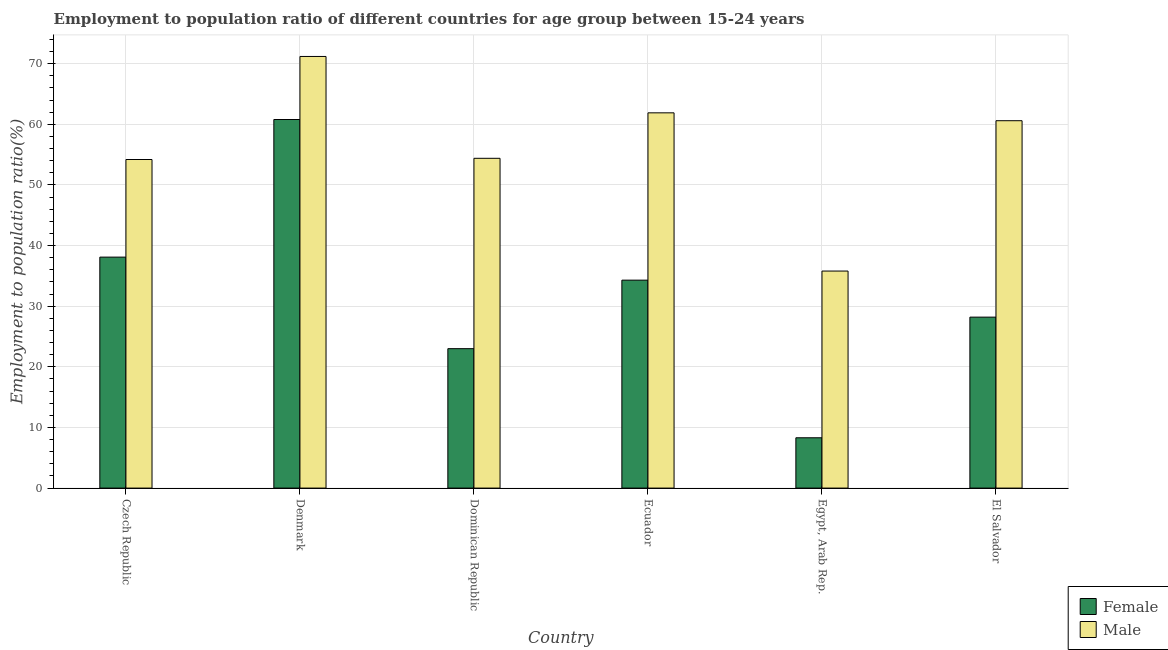Are the number of bars per tick equal to the number of legend labels?
Give a very brief answer. Yes. Are the number of bars on each tick of the X-axis equal?
Your answer should be very brief. Yes. How many bars are there on the 4th tick from the left?
Provide a succinct answer. 2. What is the label of the 6th group of bars from the left?
Keep it short and to the point. El Salvador. In how many cases, is the number of bars for a given country not equal to the number of legend labels?
Offer a terse response. 0. What is the employment to population ratio(female) in El Salvador?
Offer a very short reply. 28.2. Across all countries, what is the maximum employment to population ratio(male)?
Your answer should be very brief. 71.2. Across all countries, what is the minimum employment to population ratio(male)?
Your answer should be very brief. 35.8. In which country was the employment to population ratio(female) minimum?
Provide a short and direct response. Egypt, Arab Rep. What is the total employment to population ratio(male) in the graph?
Give a very brief answer. 338.1. What is the difference between the employment to population ratio(male) in Egypt, Arab Rep. and that in El Salvador?
Keep it short and to the point. -24.8. What is the difference between the employment to population ratio(female) in Egypt, Arab Rep. and the employment to population ratio(male) in Czech Republic?
Your response must be concise. -45.9. What is the average employment to population ratio(female) per country?
Give a very brief answer. 32.12. What is the difference between the employment to population ratio(male) and employment to population ratio(female) in Egypt, Arab Rep.?
Your answer should be compact. 27.5. In how many countries, is the employment to population ratio(male) greater than 46 %?
Your answer should be compact. 5. What is the ratio of the employment to population ratio(female) in Czech Republic to that in Egypt, Arab Rep.?
Keep it short and to the point. 4.59. Is the employment to population ratio(male) in Dominican Republic less than that in Egypt, Arab Rep.?
Offer a terse response. No. What is the difference between the highest and the second highest employment to population ratio(male)?
Offer a very short reply. 9.3. What is the difference between the highest and the lowest employment to population ratio(male)?
Ensure brevity in your answer.  35.4. In how many countries, is the employment to population ratio(female) greater than the average employment to population ratio(female) taken over all countries?
Your response must be concise. 3. Is the sum of the employment to population ratio(male) in Czech Republic and Denmark greater than the maximum employment to population ratio(female) across all countries?
Offer a terse response. Yes. What does the 2nd bar from the left in El Salvador represents?
Your answer should be compact. Male. What does the 1st bar from the right in Czech Republic represents?
Offer a terse response. Male. How many bars are there?
Give a very brief answer. 12. How many countries are there in the graph?
Ensure brevity in your answer.  6. Does the graph contain any zero values?
Give a very brief answer. No. Does the graph contain grids?
Keep it short and to the point. Yes. Where does the legend appear in the graph?
Your response must be concise. Bottom right. What is the title of the graph?
Keep it short and to the point. Employment to population ratio of different countries for age group between 15-24 years. Does "Registered firms" appear as one of the legend labels in the graph?
Keep it short and to the point. No. What is the label or title of the Y-axis?
Your answer should be very brief. Employment to population ratio(%). What is the Employment to population ratio(%) of Female in Czech Republic?
Your response must be concise. 38.1. What is the Employment to population ratio(%) of Male in Czech Republic?
Your response must be concise. 54.2. What is the Employment to population ratio(%) in Female in Denmark?
Make the answer very short. 60.8. What is the Employment to population ratio(%) in Male in Denmark?
Keep it short and to the point. 71.2. What is the Employment to population ratio(%) of Male in Dominican Republic?
Keep it short and to the point. 54.4. What is the Employment to population ratio(%) in Female in Ecuador?
Provide a short and direct response. 34.3. What is the Employment to population ratio(%) of Male in Ecuador?
Provide a short and direct response. 61.9. What is the Employment to population ratio(%) of Female in Egypt, Arab Rep.?
Your response must be concise. 8.3. What is the Employment to population ratio(%) in Male in Egypt, Arab Rep.?
Offer a very short reply. 35.8. What is the Employment to population ratio(%) in Female in El Salvador?
Ensure brevity in your answer.  28.2. What is the Employment to population ratio(%) of Male in El Salvador?
Offer a very short reply. 60.6. Across all countries, what is the maximum Employment to population ratio(%) in Female?
Ensure brevity in your answer.  60.8. Across all countries, what is the maximum Employment to population ratio(%) in Male?
Ensure brevity in your answer.  71.2. Across all countries, what is the minimum Employment to population ratio(%) of Female?
Make the answer very short. 8.3. Across all countries, what is the minimum Employment to population ratio(%) of Male?
Provide a succinct answer. 35.8. What is the total Employment to population ratio(%) in Female in the graph?
Give a very brief answer. 192.7. What is the total Employment to population ratio(%) in Male in the graph?
Offer a terse response. 338.1. What is the difference between the Employment to population ratio(%) of Female in Czech Republic and that in Denmark?
Give a very brief answer. -22.7. What is the difference between the Employment to population ratio(%) of Female in Czech Republic and that in Egypt, Arab Rep.?
Provide a short and direct response. 29.8. What is the difference between the Employment to population ratio(%) of Female in Denmark and that in Dominican Republic?
Your response must be concise. 37.8. What is the difference between the Employment to population ratio(%) in Male in Denmark and that in Dominican Republic?
Offer a terse response. 16.8. What is the difference between the Employment to population ratio(%) in Female in Denmark and that in Ecuador?
Keep it short and to the point. 26.5. What is the difference between the Employment to population ratio(%) in Male in Denmark and that in Ecuador?
Offer a very short reply. 9.3. What is the difference between the Employment to population ratio(%) of Female in Denmark and that in Egypt, Arab Rep.?
Ensure brevity in your answer.  52.5. What is the difference between the Employment to population ratio(%) of Male in Denmark and that in Egypt, Arab Rep.?
Keep it short and to the point. 35.4. What is the difference between the Employment to population ratio(%) of Female in Denmark and that in El Salvador?
Provide a succinct answer. 32.6. What is the difference between the Employment to population ratio(%) of Female in Dominican Republic and that in Ecuador?
Provide a short and direct response. -11.3. What is the difference between the Employment to population ratio(%) of Male in Dominican Republic and that in Ecuador?
Your answer should be very brief. -7.5. What is the difference between the Employment to population ratio(%) in Female in Ecuador and that in Egypt, Arab Rep.?
Offer a terse response. 26. What is the difference between the Employment to population ratio(%) in Male in Ecuador and that in Egypt, Arab Rep.?
Your response must be concise. 26.1. What is the difference between the Employment to population ratio(%) in Female in Ecuador and that in El Salvador?
Keep it short and to the point. 6.1. What is the difference between the Employment to population ratio(%) of Female in Egypt, Arab Rep. and that in El Salvador?
Offer a terse response. -19.9. What is the difference between the Employment to population ratio(%) in Male in Egypt, Arab Rep. and that in El Salvador?
Offer a very short reply. -24.8. What is the difference between the Employment to population ratio(%) of Female in Czech Republic and the Employment to population ratio(%) of Male in Denmark?
Your response must be concise. -33.1. What is the difference between the Employment to population ratio(%) of Female in Czech Republic and the Employment to population ratio(%) of Male in Dominican Republic?
Make the answer very short. -16.3. What is the difference between the Employment to population ratio(%) in Female in Czech Republic and the Employment to population ratio(%) in Male in Ecuador?
Offer a terse response. -23.8. What is the difference between the Employment to population ratio(%) in Female in Czech Republic and the Employment to population ratio(%) in Male in El Salvador?
Ensure brevity in your answer.  -22.5. What is the difference between the Employment to population ratio(%) of Female in Denmark and the Employment to population ratio(%) of Male in El Salvador?
Keep it short and to the point. 0.2. What is the difference between the Employment to population ratio(%) in Female in Dominican Republic and the Employment to population ratio(%) in Male in Ecuador?
Your response must be concise. -38.9. What is the difference between the Employment to population ratio(%) of Female in Dominican Republic and the Employment to population ratio(%) of Male in El Salvador?
Offer a terse response. -37.6. What is the difference between the Employment to population ratio(%) in Female in Ecuador and the Employment to population ratio(%) in Male in Egypt, Arab Rep.?
Offer a terse response. -1.5. What is the difference between the Employment to population ratio(%) in Female in Ecuador and the Employment to population ratio(%) in Male in El Salvador?
Your response must be concise. -26.3. What is the difference between the Employment to population ratio(%) of Female in Egypt, Arab Rep. and the Employment to population ratio(%) of Male in El Salvador?
Provide a succinct answer. -52.3. What is the average Employment to population ratio(%) in Female per country?
Offer a terse response. 32.12. What is the average Employment to population ratio(%) in Male per country?
Offer a terse response. 56.35. What is the difference between the Employment to population ratio(%) in Female and Employment to population ratio(%) in Male in Czech Republic?
Keep it short and to the point. -16.1. What is the difference between the Employment to population ratio(%) in Female and Employment to population ratio(%) in Male in Dominican Republic?
Provide a short and direct response. -31.4. What is the difference between the Employment to population ratio(%) in Female and Employment to population ratio(%) in Male in Ecuador?
Provide a succinct answer. -27.6. What is the difference between the Employment to population ratio(%) in Female and Employment to population ratio(%) in Male in Egypt, Arab Rep.?
Offer a very short reply. -27.5. What is the difference between the Employment to population ratio(%) of Female and Employment to population ratio(%) of Male in El Salvador?
Keep it short and to the point. -32.4. What is the ratio of the Employment to population ratio(%) of Female in Czech Republic to that in Denmark?
Offer a terse response. 0.63. What is the ratio of the Employment to population ratio(%) in Male in Czech Republic to that in Denmark?
Ensure brevity in your answer.  0.76. What is the ratio of the Employment to population ratio(%) in Female in Czech Republic to that in Dominican Republic?
Provide a succinct answer. 1.66. What is the ratio of the Employment to population ratio(%) of Male in Czech Republic to that in Dominican Republic?
Offer a terse response. 1. What is the ratio of the Employment to population ratio(%) of Female in Czech Republic to that in Ecuador?
Make the answer very short. 1.11. What is the ratio of the Employment to population ratio(%) in Male in Czech Republic to that in Ecuador?
Your answer should be compact. 0.88. What is the ratio of the Employment to population ratio(%) of Female in Czech Republic to that in Egypt, Arab Rep.?
Your response must be concise. 4.59. What is the ratio of the Employment to population ratio(%) of Male in Czech Republic to that in Egypt, Arab Rep.?
Make the answer very short. 1.51. What is the ratio of the Employment to population ratio(%) of Female in Czech Republic to that in El Salvador?
Offer a very short reply. 1.35. What is the ratio of the Employment to population ratio(%) in Male in Czech Republic to that in El Salvador?
Ensure brevity in your answer.  0.89. What is the ratio of the Employment to population ratio(%) of Female in Denmark to that in Dominican Republic?
Offer a very short reply. 2.64. What is the ratio of the Employment to population ratio(%) in Male in Denmark to that in Dominican Republic?
Your response must be concise. 1.31. What is the ratio of the Employment to population ratio(%) of Female in Denmark to that in Ecuador?
Make the answer very short. 1.77. What is the ratio of the Employment to population ratio(%) of Male in Denmark to that in Ecuador?
Offer a very short reply. 1.15. What is the ratio of the Employment to population ratio(%) of Female in Denmark to that in Egypt, Arab Rep.?
Provide a succinct answer. 7.33. What is the ratio of the Employment to population ratio(%) of Male in Denmark to that in Egypt, Arab Rep.?
Give a very brief answer. 1.99. What is the ratio of the Employment to population ratio(%) in Female in Denmark to that in El Salvador?
Offer a terse response. 2.16. What is the ratio of the Employment to population ratio(%) in Male in Denmark to that in El Salvador?
Your answer should be very brief. 1.17. What is the ratio of the Employment to population ratio(%) of Female in Dominican Republic to that in Ecuador?
Offer a very short reply. 0.67. What is the ratio of the Employment to population ratio(%) of Male in Dominican Republic to that in Ecuador?
Offer a very short reply. 0.88. What is the ratio of the Employment to population ratio(%) of Female in Dominican Republic to that in Egypt, Arab Rep.?
Make the answer very short. 2.77. What is the ratio of the Employment to population ratio(%) in Male in Dominican Republic to that in Egypt, Arab Rep.?
Provide a succinct answer. 1.52. What is the ratio of the Employment to population ratio(%) of Female in Dominican Republic to that in El Salvador?
Keep it short and to the point. 0.82. What is the ratio of the Employment to population ratio(%) of Male in Dominican Republic to that in El Salvador?
Provide a short and direct response. 0.9. What is the ratio of the Employment to population ratio(%) in Female in Ecuador to that in Egypt, Arab Rep.?
Provide a short and direct response. 4.13. What is the ratio of the Employment to population ratio(%) in Male in Ecuador to that in Egypt, Arab Rep.?
Your answer should be compact. 1.73. What is the ratio of the Employment to population ratio(%) in Female in Ecuador to that in El Salvador?
Provide a succinct answer. 1.22. What is the ratio of the Employment to population ratio(%) of Male in Ecuador to that in El Salvador?
Your response must be concise. 1.02. What is the ratio of the Employment to population ratio(%) in Female in Egypt, Arab Rep. to that in El Salvador?
Your answer should be very brief. 0.29. What is the ratio of the Employment to population ratio(%) in Male in Egypt, Arab Rep. to that in El Salvador?
Your answer should be very brief. 0.59. What is the difference between the highest and the second highest Employment to population ratio(%) in Female?
Your answer should be very brief. 22.7. What is the difference between the highest and the second highest Employment to population ratio(%) in Male?
Your answer should be very brief. 9.3. What is the difference between the highest and the lowest Employment to population ratio(%) in Female?
Your answer should be compact. 52.5. What is the difference between the highest and the lowest Employment to population ratio(%) of Male?
Make the answer very short. 35.4. 